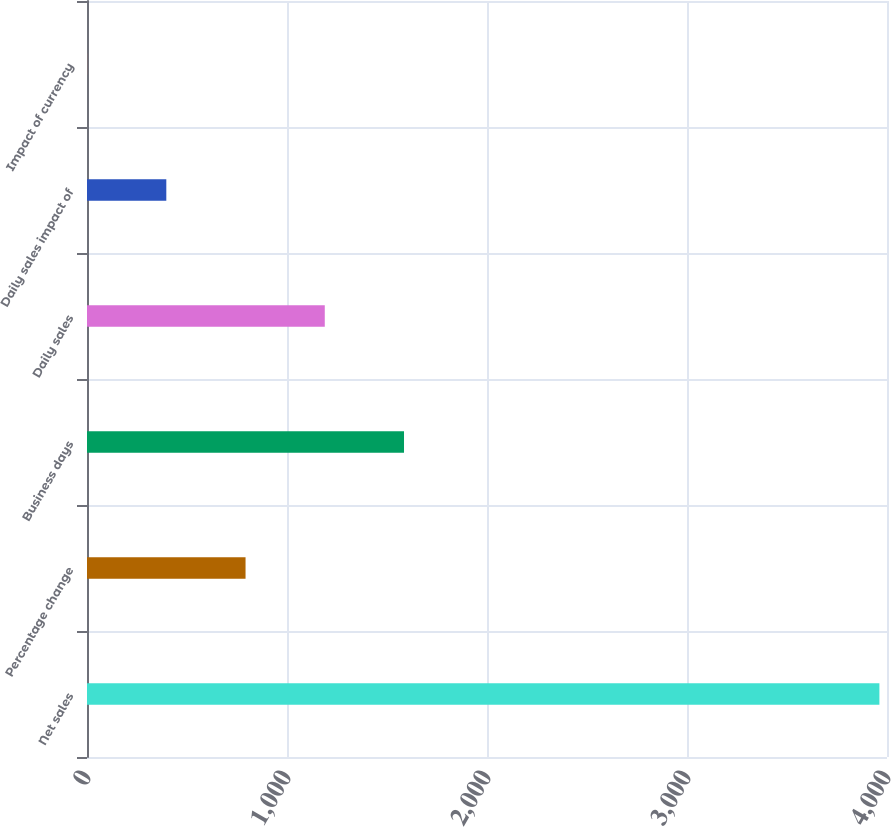<chart> <loc_0><loc_0><loc_500><loc_500><bar_chart><fcel>Net sales<fcel>Percentage change<fcel>Business days<fcel>Daily sales<fcel>Daily sales impact of<fcel>Impact of currency<nl><fcel>3962<fcel>792.72<fcel>1585.04<fcel>1188.88<fcel>396.56<fcel>0.4<nl></chart> 